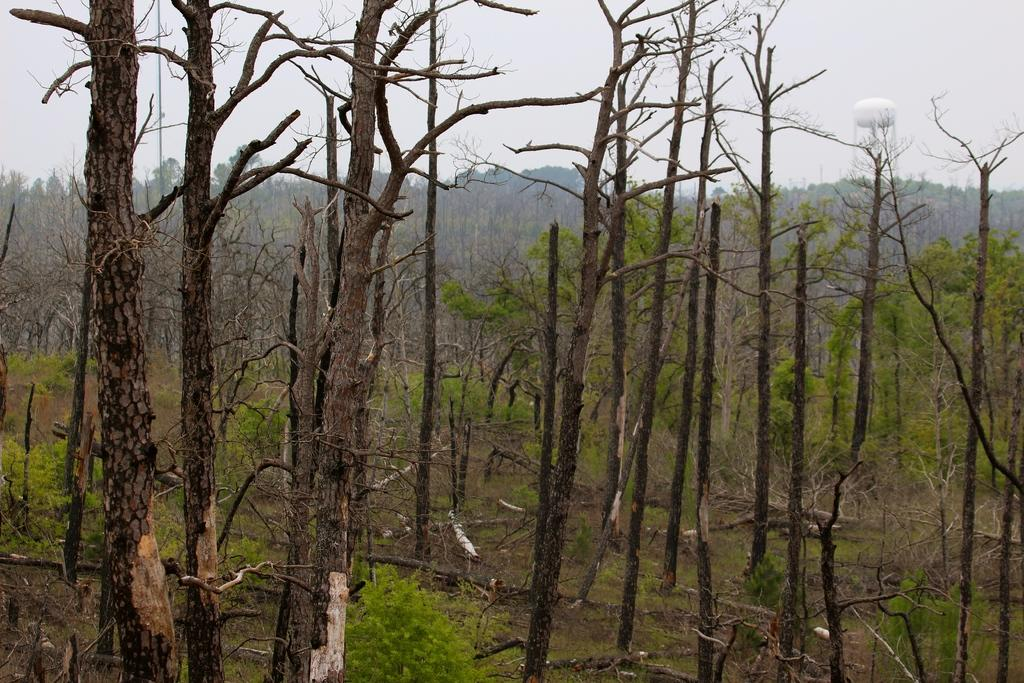What type of vegetation can be seen in the image? There are trees in the image. What material are the trunks made of in the image? The trunks in the image are made of wood. What structure can be seen in the background of the image? There is a tower visible in the background of the image. What class is being taught in the image? There is no class or teaching activity depicted in the image. What is the height of the wrist in the image? There is no wrist or person present in the image. 